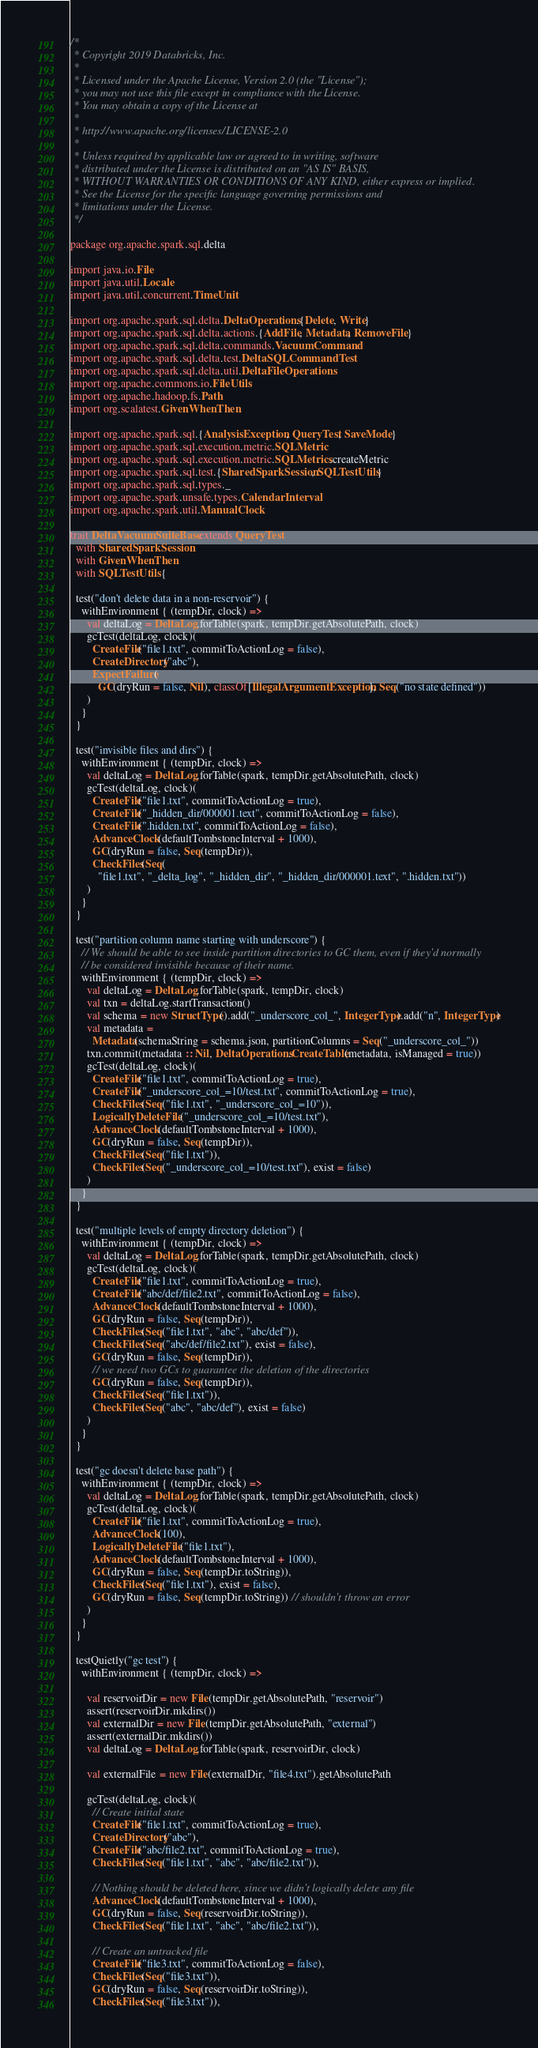Convert code to text. <code><loc_0><loc_0><loc_500><loc_500><_Scala_>/*
 * Copyright 2019 Databricks, Inc.
 *
 * Licensed under the Apache License, Version 2.0 (the "License");
 * you may not use this file except in compliance with the License.
 * You may obtain a copy of the License at
 *
 * http://www.apache.org/licenses/LICENSE-2.0
 *
 * Unless required by applicable law or agreed to in writing, software
 * distributed under the License is distributed on an "AS IS" BASIS,
 * WITHOUT WARRANTIES OR CONDITIONS OF ANY KIND, either express or implied.
 * See the License for the specific language governing permissions and
 * limitations under the License.
 */

package org.apache.spark.sql.delta

import java.io.File
import java.util.Locale
import java.util.concurrent.TimeUnit

import org.apache.spark.sql.delta.DeltaOperations.{Delete, Write}
import org.apache.spark.sql.delta.actions.{AddFile, Metadata, RemoveFile}
import org.apache.spark.sql.delta.commands.VacuumCommand
import org.apache.spark.sql.delta.test.DeltaSQLCommandTest
import org.apache.spark.sql.delta.util.DeltaFileOperations
import org.apache.commons.io.FileUtils
import org.apache.hadoop.fs.Path
import org.scalatest.GivenWhenThen

import org.apache.spark.sql.{AnalysisException, QueryTest, SaveMode}
import org.apache.spark.sql.execution.metric.SQLMetric
import org.apache.spark.sql.execution.metric.SQLMetrics.createMetric
import org.apache.spark.sql.test.{SharedSparkSession, SQLTestUtils}
import org.apache.spark.sql.types._
import org.apache.spark.unsafe.types.CalendarInterval
import org.apache.spark.util.ManualClock

trait DeltaVacuumSuiteBase extends QueryTest
  with SharedSparkSession
  with GivenWhenThen
  with SQLTestUtils {

  test("don't delete data in a non-reservoir") {
    withEnvironment { (tempDir, clock) =>
      val deltaLog = DeltaLog.forTable(spark, tempDir.getAbsolutePath, clock)
      gcTest(deltaLog, clock)(
        CreateFile("file1.txt", commitToActionLog = false),
        CreateDirectory("abc"),
        ExpectFailure(
          GC(dryRun = false, Nil), classOf[IllegalArgumentException], Seq("no state defined"))
      )
    }
  }

  test("invisible files and dirs") {
    withEnvironment { (tempDir, clock) =>
      val deltaLog = DeltaLog.forTable(spark, tempDir.getAbsolutePath, clock)
      gcTest(deltaLog, clock)(
        CreateFile("file1.txt", commitToActionLog = true),
        CreateFile("_hidden_dir/000001.text", commitToActionLog = false),
        CreateFile(".hidden.txt", commitToActionLog = false),
        AdvanceClock(defaultTombstoneInterval + 1000),
        GC(dryRun = false, Seq(tempDir)),
        CheckFiles(Seq(
          "file1.txt", "_delta_log", "_hidden_dir", "_hidden_dir/000001.text", ".hidden.txt"))
      )
    }
  }

  test("partition column name starting with underscore") {
    // We should be able to see inside partition directories to GC them, even if they'd normally
    // be considered invisible because of their name.
    withEnvironment { (tempDir, clock) =>
      val deltaLog = DeltaLog.forTable(spark, tempDir, clock)
      val txn = deltaLog.startTransaction()
      val schema = new StructType().add("_underscore_col_", IntegerType).add("n", IntegerType)
      val metadata =
        Metadata(schemaString = schema.json, partitionColumns = Seq("_underscore_col_"))
      txn.commit(metadata :: Nil, DeltaOperations.CreateTable(metadata, isManaged = true))
      gcTest(deltaLog, clock)(
        CreateFile("file1.txt", commitToActionLog = true),
        CreateFile("_underscore_col_=10/test.txt", commitToActionLog = true),
        CheckFiles(Seq("file1.txt", "_underscore_col_=10")),
        LogicallyDeleteFile("_underscore_col_=10/test.txt"),
        AdvanceClock(defaultTombstoneInterval + 1000),
        GC(dryRun = false, Seq(tempDir)),
        CheckFiles(Seq("file1.txt")),
        CheckFiles(Seq("_underscore_col_=10/test.txt"), exist = false)
      )
    }
  }

  test("multiple levels of empty directory deletion") {
    withEnvironment { (tempDir, clock) =>
      val deltaLog = DeltaLog.forTable(spark, tempDir.getAbsolutePath, clock)
      gcTest(deltaLog, clock)(
        CreateFile("file1.txt", commitToActionLog = true),
        CreateFile("abc/def/file2.txt", commitToActionLog = false),
        AdvanceClock(defaultTombstoneInterval + 1000),
        GC(dryRun = false, Seq(tempDir)),
        CheckFiles(Seq("file1.txt", "abc", "abc/def")),
        CheckFiles(Seq("abc/def/file2.txt"), exist = false),
        GC(dryRun = false, Seq(tempDir)),
        // we need two GCs to guarantee the deletion of the directories
        GC(dryRun = false, Seq(tempDir)),
        CheckFiles(Seq("file1.txt")),
        CheckFiles(Seq("abc", "abc/def"), exist = false)
      )
    }
  }

  test("gc doesn't delete base path") {
    withEnvironment { (tempDir, clock) =>
      val deltaLog = DeltaLog.forTable(spark, tempDir.getAbsolutePath, clock)
      gcTest(deltaLog, clock)(
        CreateFile("file1.txt", commitToActionLog = true),
        AdvanceClock(100),
        LogicallyDeleteFile("file1.txt"),
        AdvanceClock(defaultTombstoneInterval + 1000),
        GC(dryRun = false, Seq(tempDir.toString)),
        CheckFiles(Seq("file1.txt"), exist = false),
        GC(dryRun = false, Seq(tempDir.toString)) // shouldn't throw an error
      )
    }
  }

  testQuietly("gc test") {
    withEnvironment { (tempDir, clock) =>

      val reservoirDir = new File(tempDir.getAbsolutePath, "reservoir")
      assert(reservoirDir.mkdirs())
      val externalDir = new File(tempDir.getAbsolutePath, "external")
      assert(externalDir.mkdirs())
      val deltaLog = DeltaLog.forTable(spark, reservoirDir, clock)

      val externalFile = new File(externalDir, "file4.txt").getAbsolutePath

      gcTest(deltaLog, clock)(
        // Create initial state
        CreateFile("file1.txt", commitToActionLog = true),
        CreateDirectory("abc"),
        CreateFile("abc/file2.txt", commitToActionLog = true),
        CheckFiles(Seq("file1.txt", "abc", "abc/file2.txt")),

        // Nothing should be deleted here, since we didn't logically delete any file
        AdvanceClock(defaultTombstoneInterval + 1000),
        GC(dryRun = false, Seq(reservoirDir.toString)),
        CheckFiles(Seq("file1.txt", "abc", "abc/file2.txt")),

        // Create an untracked file
        CreateFile("file3.txt", commitToActionLog = false),
        CheckFiles(Seq("file3.txt")),
        GC(dryRun = false, Seq(reservoirDir.toString)),
        CheckFiles(Seq("file3.txt")),</code> 